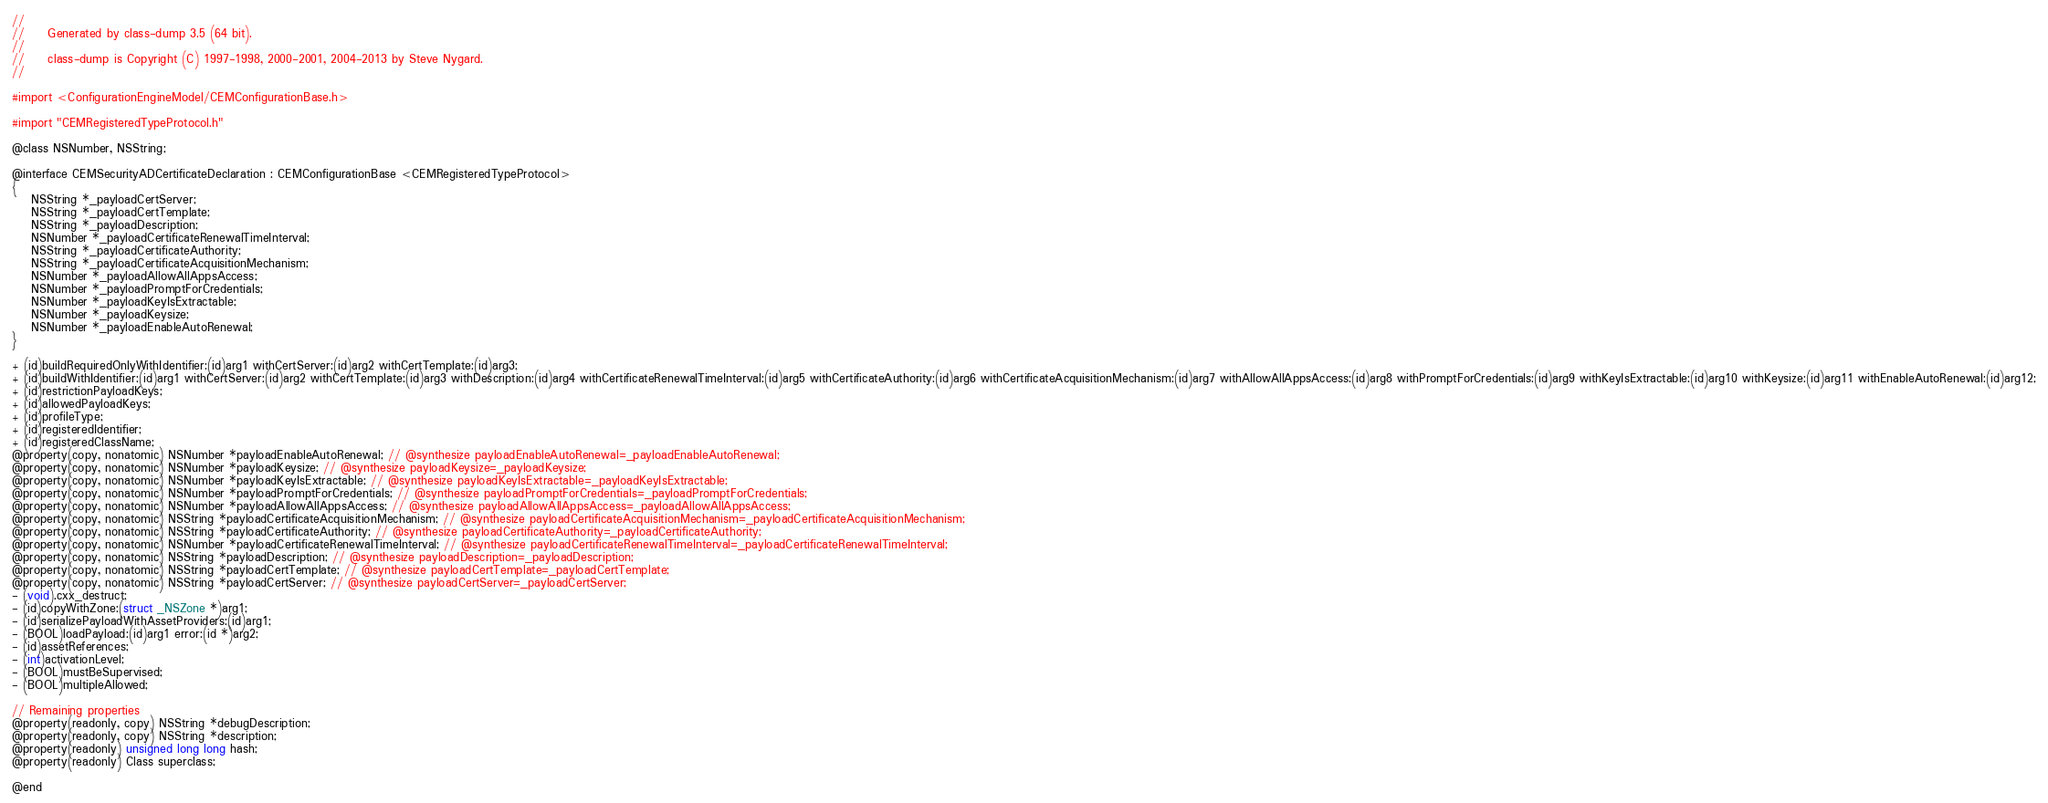<code> <loc_0><loc_0><loc_500><loc_500><_C_>//
//     Generated by class-dump 3.5 (64 bit).
//
//     class-dump is Copyright (C) 1997-1998, 2000-2001, 2004-2013 by Steve Nygard.
//

#import <ConfigurationEngineModel/CEMConfigurationBase.h>

#import "CEMRegisteredTypeProtocol.h"

@class NSNumber, NSString;

@interface CEMSecurityADCertificateDeclaration : CEMConfigurationBase <CEMRegisteredTypeProtocol>
{
    NSString *_payloadCertServer;
    NSString *_payloadCertTemplate;
    NSString *_payloadDescription;
    NSNumber *_payloadCertificateRenewalTimeInterval;
    NSString *_payloadCertificateAuthority;
    NSString *_payloadCertificateAcquisitionMechanism;
    NSNumber *_payloadAllowAllAppsAccess;
    NSNumber *_payloadPromptForCredentials;
    NSNumber *_payloadKeyIsExtractable;
    NSNumber *_payloadKeysize;
    NSNumber *_payloadEnableAutoRenewal;
}

+ (id)buildRequiredOnlyWithIdentifier:(id)arg1 withCertServer:(id)arg2 withCertTemplate:(id)arg3;
+ (id)buildWithIdentifier:(id)arg1 withCertServer:(id)arg2 withCertTemplate:(id)arg3 withDescription:(id)arg4 withCertificateRenewalTimeInterval:(id)arg5 withCertificateAuthority:(id)arg6 withCertificateAcquisitionMechanism:(id)arg7 withAllowAllAppsAccess:(id)arg8 withPromptForCredentials:(id)arg9 withKeyIsExtractable:(id)arg10 withKeysize:(id)arg11 withEnableAutoRenewal:(id)arg12;
+ (id)restrictionPayloadKeys;
+ (id)allowedPayloadKeys;
+ (id)profileType;
+ (id)registeredIdentifier;
+ (id)registeredClassName;
@property(copy, nonatomic) NSNumber *payloadEnableAutoRenewal; // @synthesize payloadEnableAutoRenewal=_payloadEnableAutoRenewal;
@property(copy, nonatomic) NSNumber *payloadKeysize; // @synthesize payloadKeysize=_payloadKeysize;
@property(copy, nonatomic) NSNumber *payloadKeyIsExtractable; // @synthesize payloadKeyIsExtractable=_payloadKeyIsExtractable;
@property(copy, nonatomic) NSNumber *payloadPromptForCredentials; // @synthesize payloadPromptForCredentials=_payloadPromptForCredentials;
@property(copy, nonatomic) NSNumber *payloadAllowAllAppsAccess; // @synthesize payloadAllowAllAppsAccess=_payloadAllowAllAppsAccess;
@property(copy, nonatomic) NSString *payloadCertificateAcquisitionMechanism; // @synthesize payloadCertificateAcquisitionMechanism=_payloadCertificateAcquisitionMechanism;
@property(copy, nonatomic) NSString *payloadCertificateAuthority; // @synthesize payloadCertificateAuthority=_payloadCertificateAuthority;
@property(copy, nonatomic) NSNumber *payloadCertificateRenewalTimeInterval; // @synthesize payloadCertificateRenewalTimeInterval=_payloadCertificateRenewalTimeInterval;
@property(copy, nonatomic) NSString *payloadDescription; // @synthesize payloadDescription=_payloadDescription;
@property(copy, nonatomic) NSString *payloadCertTemplate; // @synthesize payloadCertTemplate=_payloadCertTemplate;
@property(copy, nonatomic) NSString *payloadCertServer; // @synthesize payloadCertServer=_payloadCertServer;
- (void).cxx_destruct;
- (id)copyWithZone:(struct _NSZone *)arg1;
- (id)serializePayloadWithAssetProviders:(id)arg1;
- (BOOL)loadPayload:(id)arg1 error:(id *)arg2;
- (id)assetReferences;
- (int)activationLevel;
- (BOOL)mustBeSupervised;
- (BOOL)multipleAllowed;

// Remaining properties
@property(readonly, copy) NSString *debugDescription;
@property(readonly, copy) NSString *description;
@property(readonly) unsigned long long hash;
@property(readonly) Class superclass;

@end

</code> 